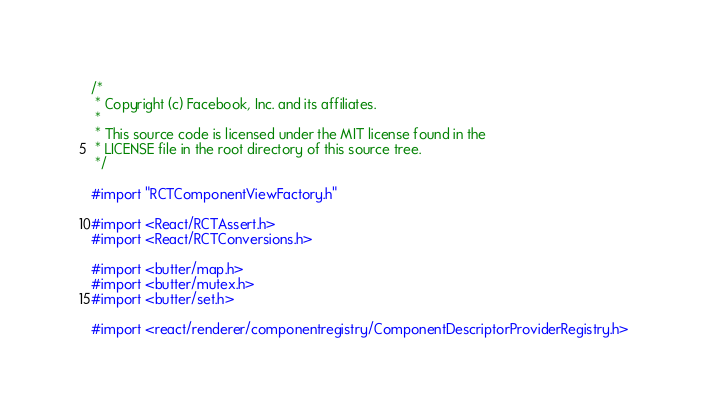Convert code to text. <code><loc_0><loc_0><loc_500><loc_500><_ObjectiveC_>/*
 * Copyright (c) Facebook, Inc. and its affiliates.
 *
 * This source code is licensed under the MIT license found in the
 * LICENSE file in the root directory of this source tree.
 */

#import "RCTComponentViewFactory.h"

#import <React/RCTAssert.h>
#import <React/RCTConversions.h>

#import <butter/map.h>
#import <butter/mutex.h>
#import <butter/set.h>

#import <react/renderer/componentregistry/ComponentDescriptorProviderRegistry.h></code> 